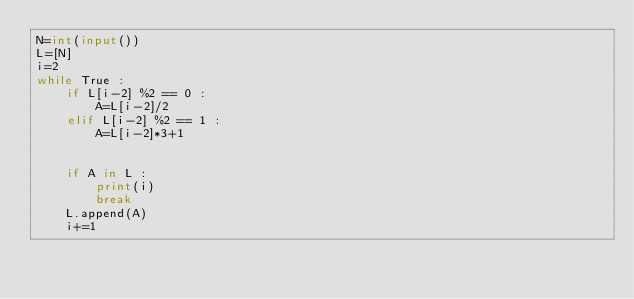<code> <loc_0><loc_0><loc_500><loc_500><_Python_>N=int(input())
L=[N]
i=2
while True :
    if L[i-2] %2 == 0 :
        A=L[i-2]/2
    elif L[i-2] %2 == 1 :
        A=L[i-2]*3+1
    
    
    if A in L :
        print(i)
        break
    L.append(A)
    i+=1</code> 